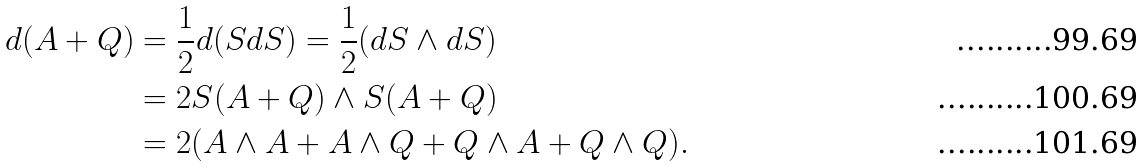<formula> <loc_0><loc_0><loc_500><loc_500>d ( A + Q ) & = \frac { 1 } { 2 } d ( S d S ) = \frac { 1 } { 2 } ( d S \wedge d S ) \\ & = 2 S ( A + Q ) \wedge S ( A + Q ) \\ & = 2 ( A \wedge A + A \wedge Q + Q \wedge A + Q \wedge Q ) .</formula> 